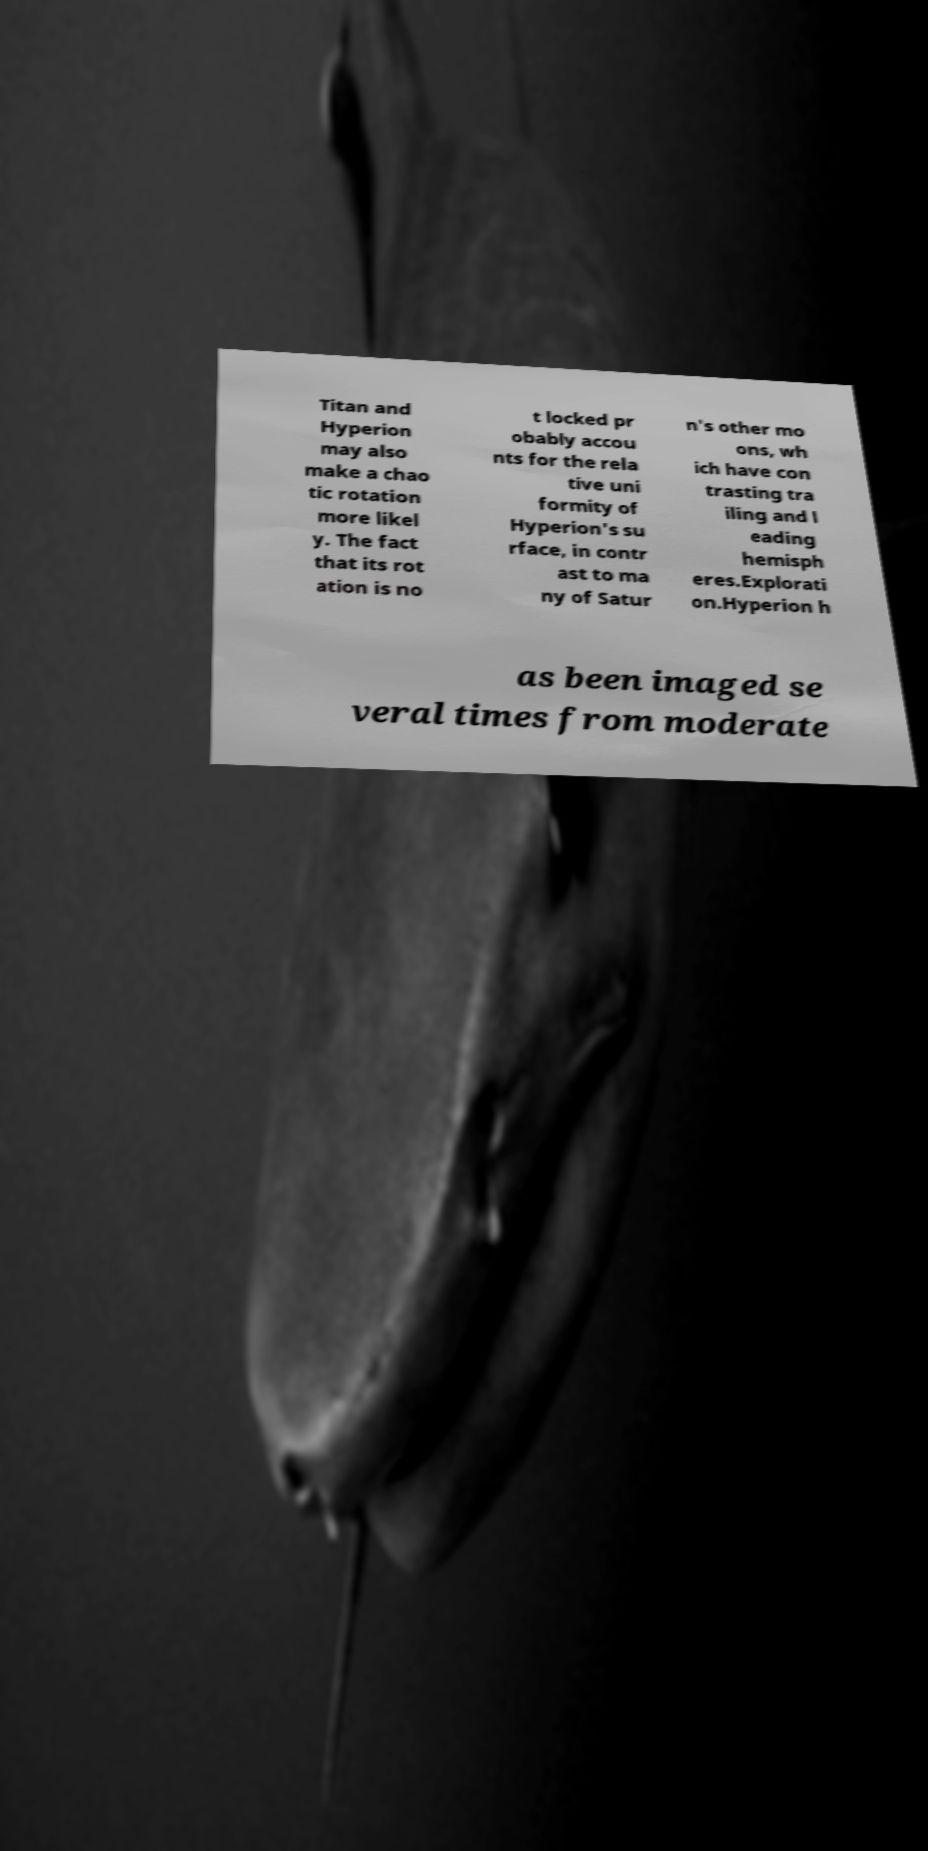For documentation purposes, I need the text within this image transcribed. Could you provide that? Titan and Hyperion may also make a chao tic rotation more likel y. The fact that its rot ation is no t locked pr obably accou nts for the rela tive uni formity of Hyperion's su rface, in contr ast to ma ny of Satur n's other mo ons, wh ich have con trasting tra iling and l eading hemisph eres.Explorati on.Hyperion h as been imaged se veral times from moderate 